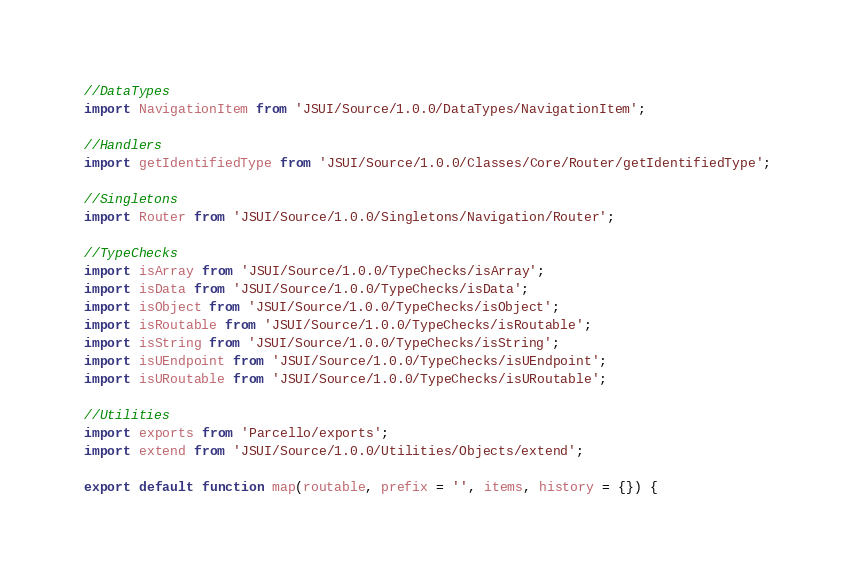<code> <loc_0><loc_0><loc_500><loc_500><_JavaScript_>
//DataTypes
import NavigationItem from 'JSUI/Source/1.0.0/DataTypes/NavigationItem';

//Handlers
import getIdentifiedType from 'JSUI/Source/1.0.0/Classes/Core/Router/getIdentifiedType';

//Singletons
import Router from 'JSUI/Source/1.0.0/Singletons/Navigation/Router';

//TypeChecks
import isArray from 'JSUI/Source/1.0.0/TypeChecks/isArray';
import isData from 'JSUI/Source/1.0.0/TypeChecks/isData';
import isObject from 'JSUI/Source/1.0.0/TypeChecks/isObject';
import isRoutable from 'JSUI/Source/1.0.0/TypeChecks/isRoutable';
import isString from 'JSUI/Source/1.0.0/TypeChecks/isString';
import isUEndpoint from 'JSUI/Source/1.0.0/TypeChecks/isUEndpoint';
import isURoutable from 'JSUI/Source/1.0.0/TypeChecks/isURoutable';

//Utilities
import exports from 'Parcello/exports';
import extend from 'JSUI/Source/1.0.0/Utilities/Objects/extend';

export default function map(routable, prefix = '', items, history = {}) {</code> 